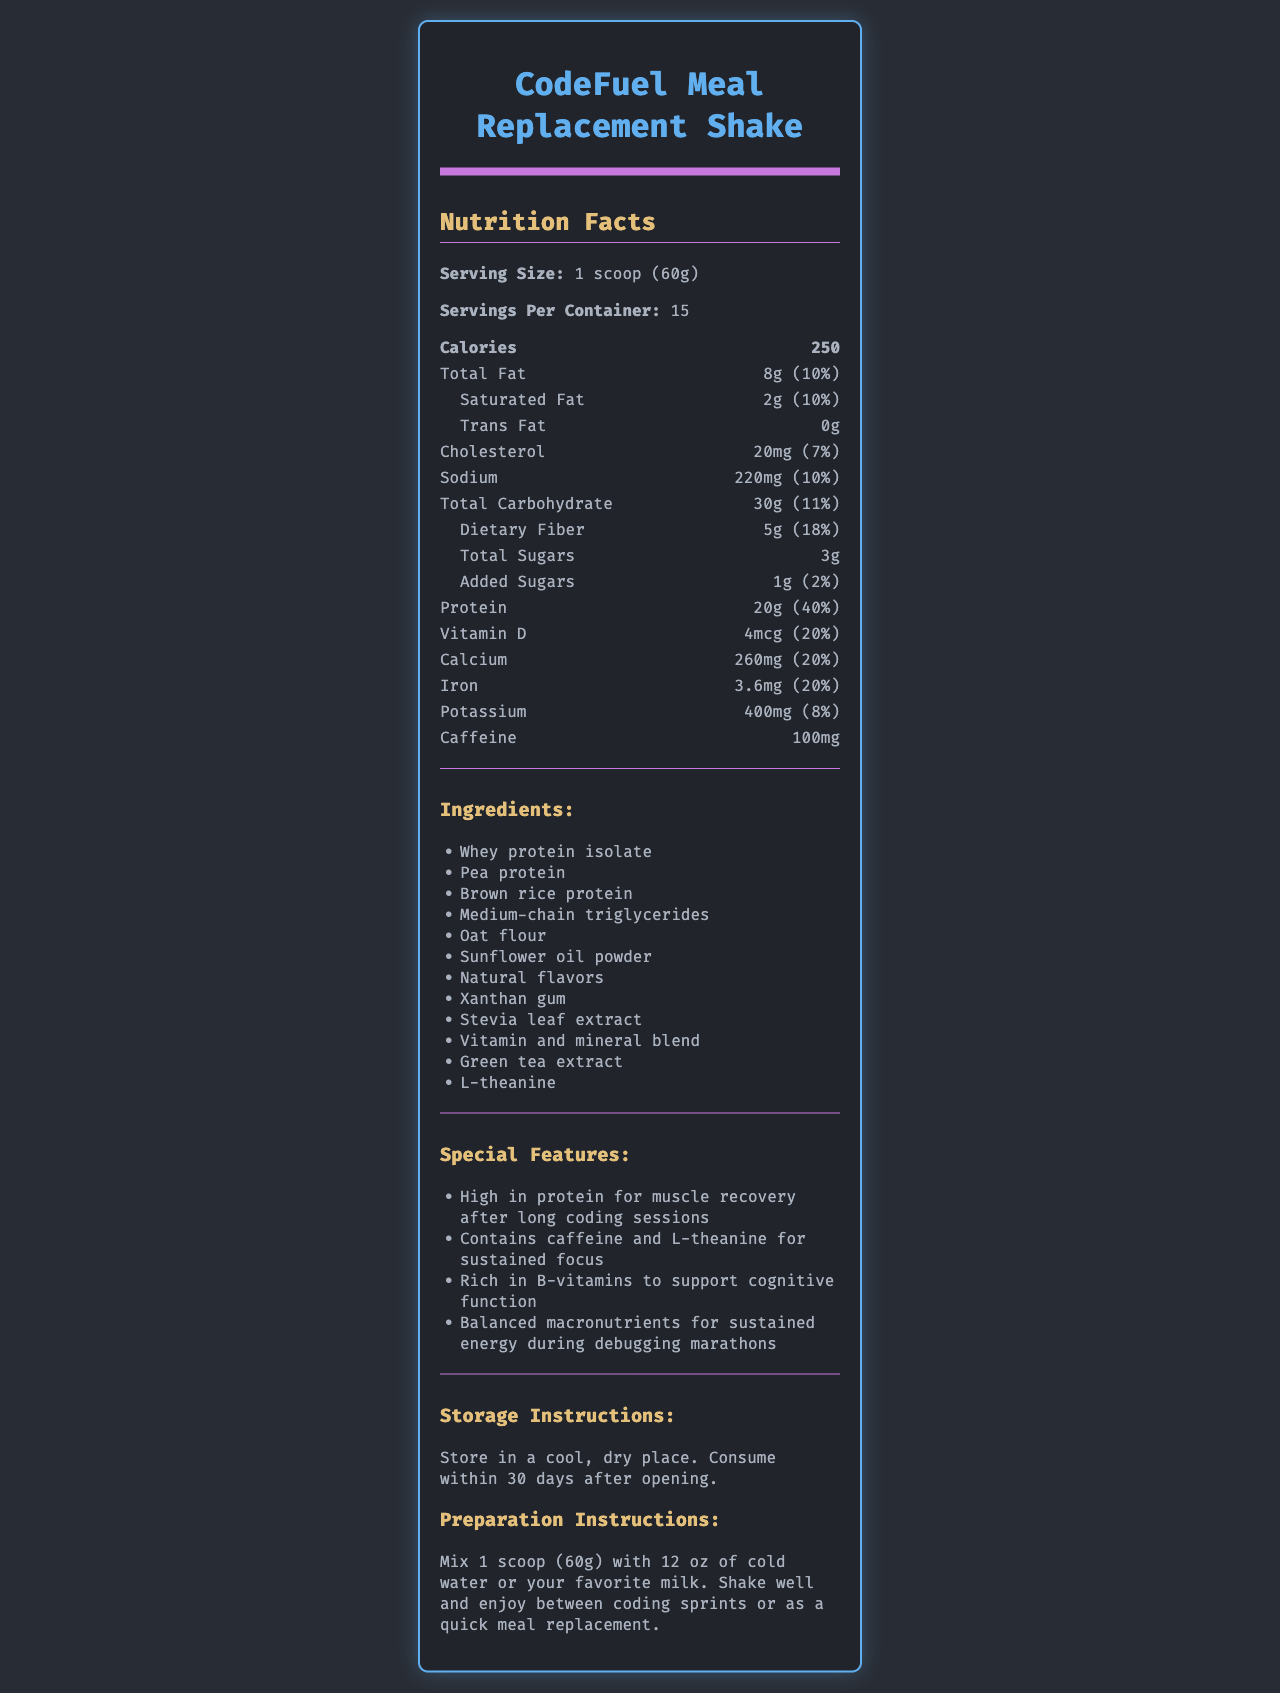what is the serving size of the CodeFuel Meal Replacement Shake? The serving size is clearly stated as "1 scoop (60g)" in the document.
Answer: 1 scoop (60g) how many calories are there per serving? The document specifies that each serving contains 250 calories.
Answer: 250 how many grams of protein are in each serving? The nutrition facts list 20g of protein per serving.
Answer: 20g what is the daily value percentage of vitamin B12 provided by one serving? The document indicates that one serving contains 50% of the daily value for vitamin B12.
Answer: 50% how many total carbohydrates are in one serving? The total carbohydrate content per serving is 30g, as listed in the nutrition facts.
Answer: 30g how much caffeine does one serving have? The document specifies that one serving contains 100mg of caffeine.
Answer: 100mg what ingredient in the shake is intended to help with muscle recovery? The special features mention "High in protein for muscle recovery," and whey protein isolate is a primary protein source listed in the ingredients.
Answer: Whey protein isolate what type of container does the CodeFuel Meal Replacement Shake come in? A. Jar B. Box C. Can D. Bottle The label specifies "Store in a cool, dry place. Consume within 30 days after opening," indicating it is likely stored in a jar with a resealable lid.
Answer: A. Jar which ingredient is used as a natural sweetener? A. Aspartame B. Stevia leaf extract C. Sucralose D. Sugar The ingredients list includes "Stevia leaf extract," a natural sweetener.
Answer: B. Stevia leaf extract does the product contain any allergens? The allergen information section states "Contains milk. Manufactured in a facility that also processes soy, tree nuts, and wheat."
Answer: Yes is this shake suitable for vegans? The document lists whey protein isolate as an ingredient, which is derived from milk and therefore not suitable for vegans.
Answer: No summarize the main features and nutritional benefits of the CodeFuel Meal Replacement Shake. The document highlights that the shake offers 20g of protein, balanced macronutrients, vitamins and minerals, and special components like caffeine for focus and B-vitamins for cognitive support. It also mentions storage and preparation instructions.
Answer: The CodeFuel Meal Replacement Shake is designed for busy developers, providing high protein content and balanced macronutrients for sustained energy and muscle recovery. It includes caffeine and L-theanine for focus, and a blend of vitamins and minerals to support overall health. what is the exact amount of vitamin E in the shake? The document does not specify the exact amount but only provides the daily value percentage for vitamin E.
Answer: Not enough information how many servings per container are there? The document lists the number of servings per container as 15.
Answer: 15 what is the daily value percentage of dietary fiber provided by one serving? The document shows that one serving provides 18% of the daily value for dietary fiber.
Answer: 18% 